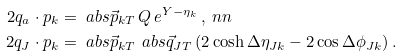<formula> <loc_0><loc_0><loc_500><loc_500>2 q _ { a } \cdot p _ { k } & = \ a b s { \vec { p } _ { k T } } \, Q \, e ^ { Y - \eta _ { k } } \, , \ n n \\ 2 q _ { J } \cdot p _ { k } & = \ a b s { \vec { p } _ { k T } } \, \ a b s { \vec { q } _ { J T } } \, ( 2 \cosh \Delta \eta _ { J k } - 2 \cos \Delta \phi _ { J k } ) \, .</formula> 